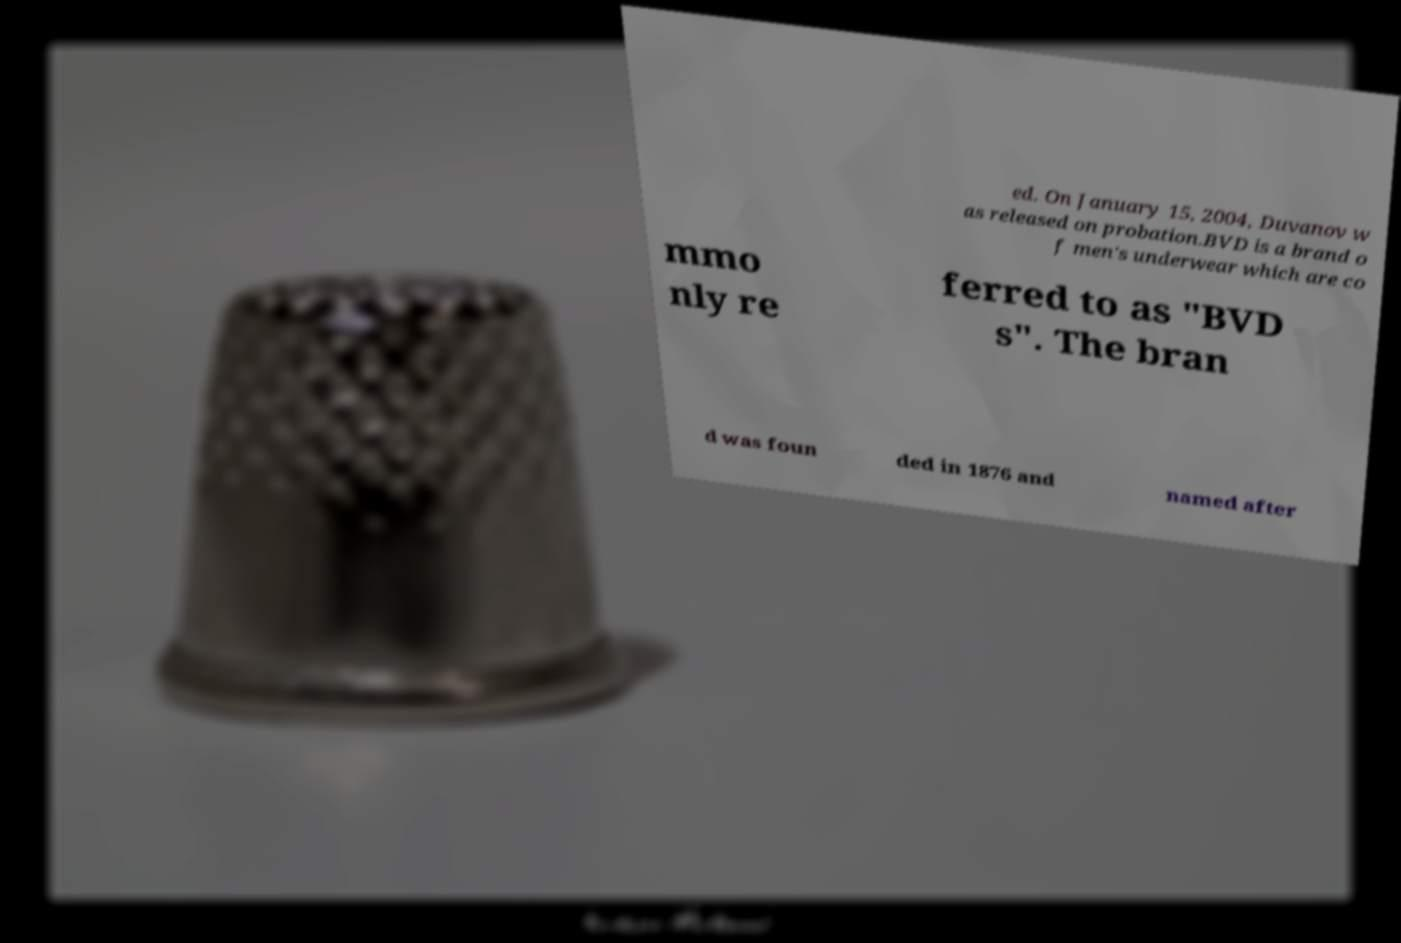Please identify and transcribe the text found in this image. ed. On January 15, 2004, Duvanov w as released on probation.BVD is a brand o f men's underwear which are co mmo nly re ferred to as "BVD s". The bran d was foun ded in 1876 and named after 